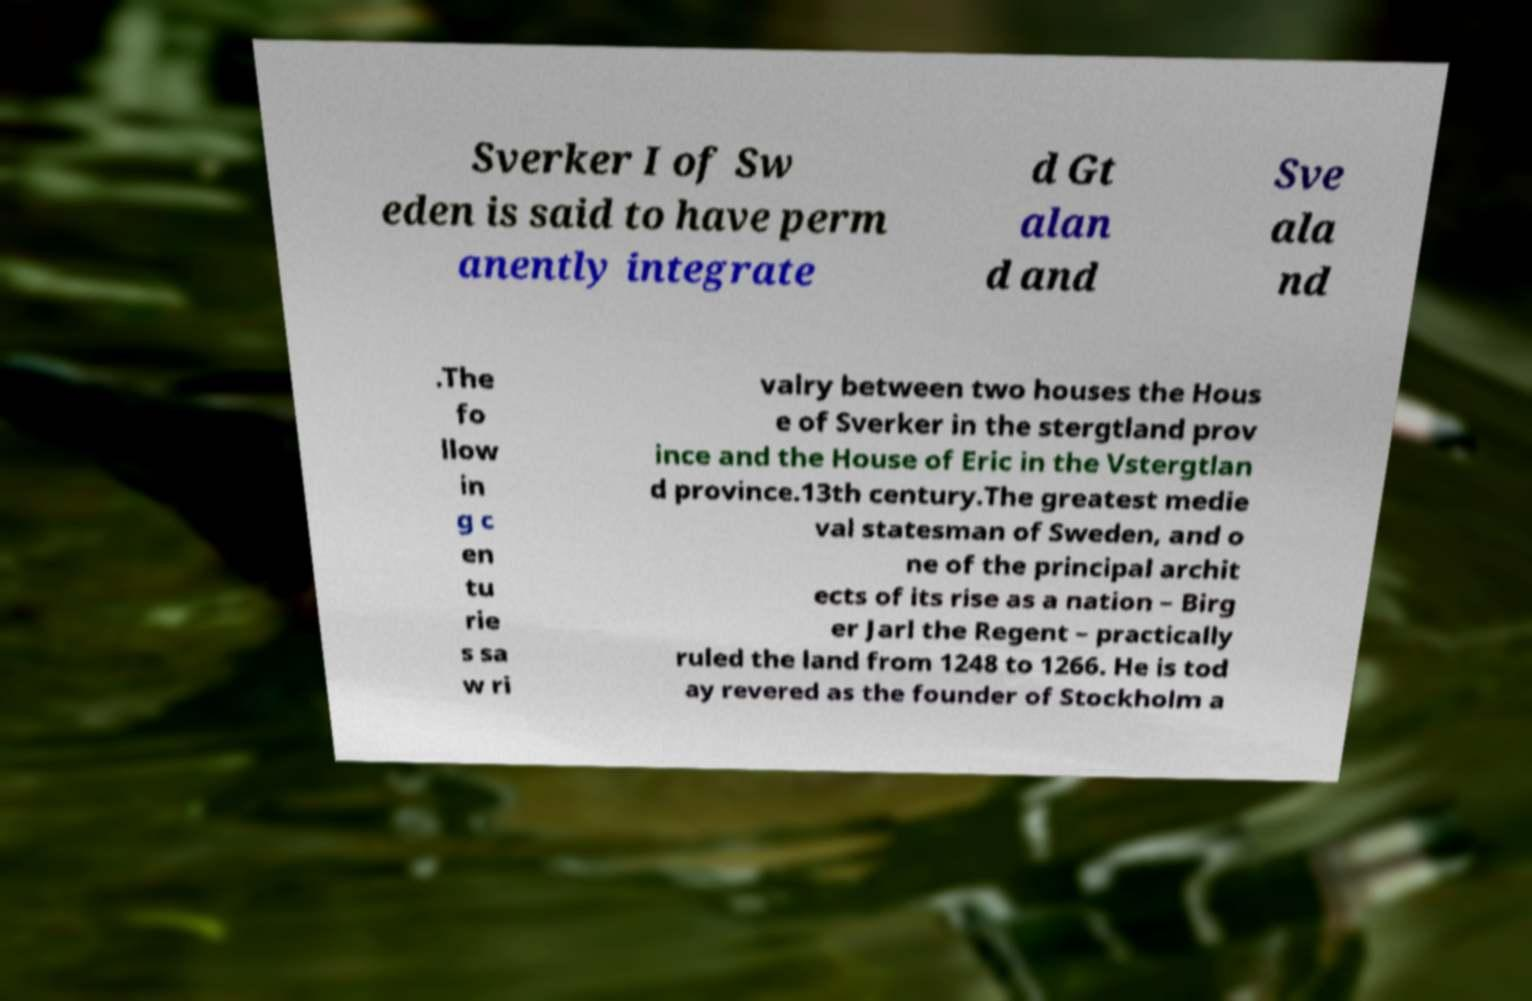Please read and relay the text visible in this image. What does it say? Sverker I of Sw eden is said to have perm anently integrate d Gt alan d and Sve ala nd .The fo llow in g c en tu rie s sa w ri valry between two houses the Hous e of Sverker in the stergtland prov ince and the House of Eric in the Vstergtlan d province.13th century.The greatest medie val statesman of Sweden, and o ne of the principal archit ects of its rise as a nation – Birg er Jarl the Regent – practically ruled the land from 1248 to 1266. He is tod ay revered as the founder of Stockholm a 